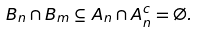<formula> <loc_0><loc_0><loc_500><loc_500>B _ { n } \cap B _ { m } \subseteq A _ { n } \cap A _ { n } ^ { c } = \emptyset .</formula> 